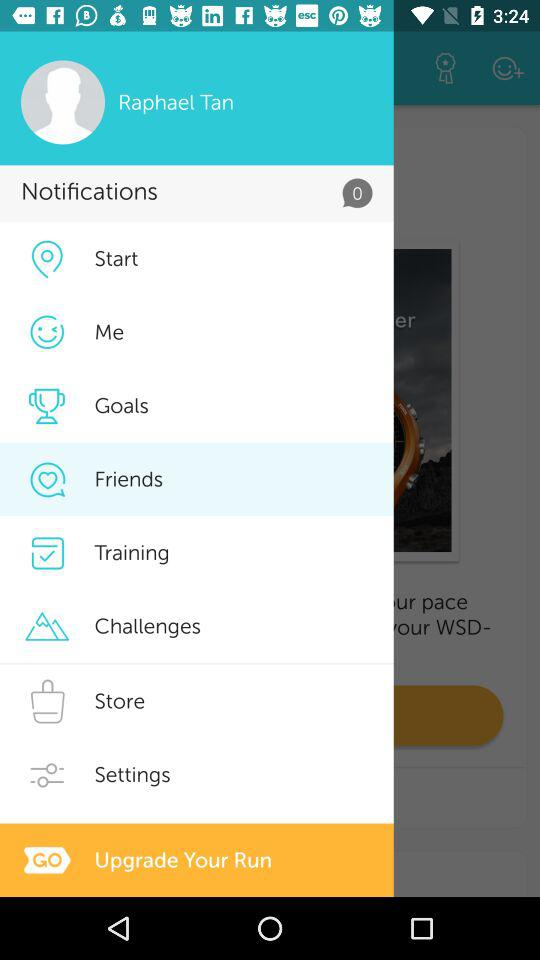Which option is highlighted? The highlighted option is "Friends". 